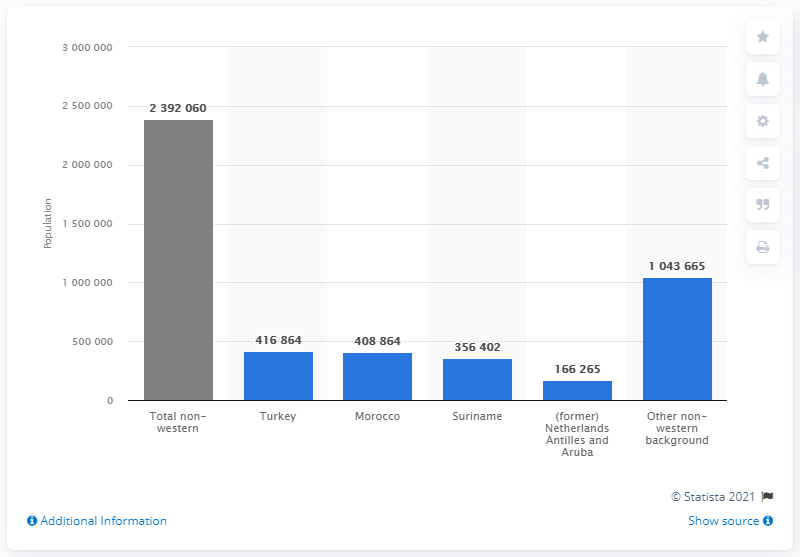Specify some key components in this picture. It is estimated that approximately 2,392,060 non-Western people reside in the Netherlands. 